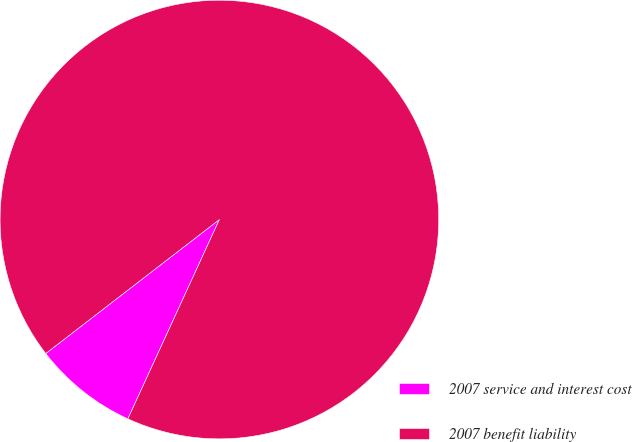Convert chart. <chart><loc_0><loc_0><loc_500><loc_500><pie_chart><fcel>2007 service and interest cost<fcel>2007 benefit liability<nl><fcel>7.69%<fcel>92.31%<nl></chart> 